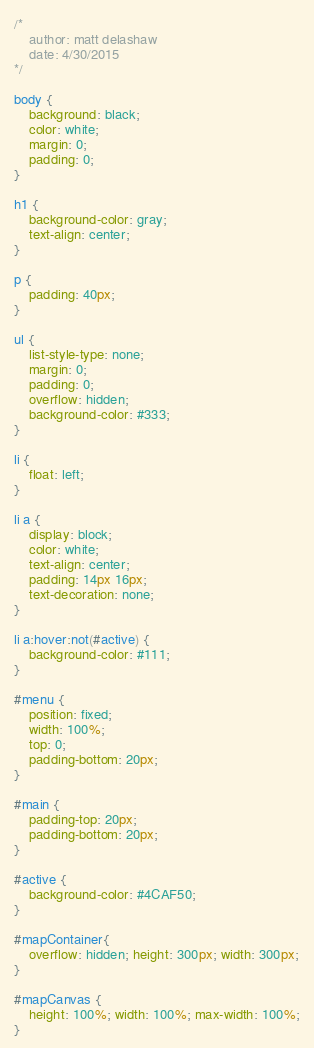Convert code to text. <code><loc_0><loc_0><loc_500><loc_500><_CSS_>/*
    author: matt delashaw
	date: 4/30/2015
*/

body {
	background: black; 
	color: white;
	margin: 0;
	padding: 0;
}

h1 {
	background-color: gray;
	text-align: center;
}

p {
	padding: 40px;
}

ul {
    list-style-type: none;
    margin: 0;
    padding: 0;
    overflow: hidden;
    background-color: #333;
}

li {
    float: left;
}

li a {
    display: block;
    color: white;
    text-align: center;
    padding: 14px 16px;
    text-decoration: none;
}

li a:hover:not(#active) {
    background-color: #111;
}

#menu {
	position: fixed;
	width: 100%;
	top: 0;
	padding-bottom: 20px;
}

#main {
	padding-top: 20px;
	padding-bottom: 20px;
}

#active {
    background-color: #4CAF50;
}

#mapContainer{
	overflow: hidden; height: 300px; width: 300px;
}

#mapCanvas {
	height: 100%; width: 100%; max-width: 100%;
}
</code> 